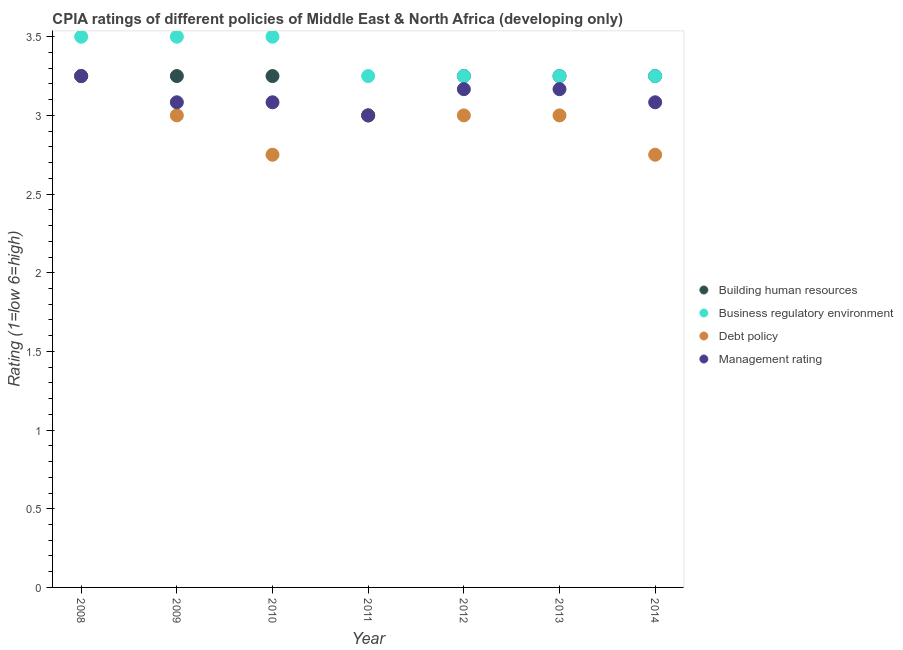How many different coloured dotlines are there?
Offer a very short reply. 4. What is the cpia rating of building human resources in 2012?
Ensure brevity in your answer.  3.25. Across all years, what is the maximum cpia rating of management?
Offer a terse response. 3.25. In which year was the cpia rating of debt policy minimum?
Offer a terse response. 2010. What is the difference between the cpia rating of building human resources in 2011 and that in 2012?
Make the answer very short. -0.25. What is the difference between the cpia rating of management in 2010 and the cpia rating of building human resources in 2013?
Make the answer very short. -0.17. What is the average cpia rating of business regulatory environment per year?
Provide a short and direct response. 3.36. In the year 2013, what is the difference between the cpia rating of management and cpia rating of debt policy?
Keep it short and to the point. 0.17. What is the ratio of the cpia rating of debt policy in 2013 to that in 2014?
Ensure brevity in your answer.  1.09. Is the difference between the cpia rating of management in 2009 and 2013 greater than the difference between the cpia rating of business regulatory environment in 2009 and 2013?
Your response must be concise. No. Is it the case that in every year, the sum of the cpia rating of building human resources and cpia rating of debt policy is greater than the sum of cpia rating of business regulatory environment and cpia rating of management?
Ensure brevity in your answer.  No. Is the cpia rating of business regulatory environment strictly less than the cpia rating of debt policy over the years?
Keep it short and to the point. No. How many dotlines are there?
Your response must be concise. 4. What is the difference between two consecutive major ticks on the Y-axis?
Provide a succinct answer. 0.5. Does the graph contain grids?
Your answer should be compact. No. Where does the legend appear in the graph?
Ensure brevity in your answer.  Center right. How many legend labels are there?
Keep it short and to the point. 4. How are the legend labels stacked?
Offer a very short reply. Vertical. What is the title of the graph?
Provide a succinct answer. CPIA ratings of different policies of Middle East & North Africa (developing only). Does "Social Assistance" appear as one of the legend labels in the graph?
Your response must be concise. No. What is the Rating (1=low 6=high) in Debt policy in 2008?
Provide a succinct answer. 3.25. What is the Rating (1=low 6=high) in Building human resources in 2009?
Your answer should be compact. 3.25. What is the Rating (1=low 6=high) in Business regulatory environment in 2009?
Your response must be concise. 3.5. What is the Rating (1=low 6=high) in Management rating in 2009?
Your response must be concise. 3.08. What is the Rating (1=low 6=high) of Building human resources in 2010?
Provide a succinct answer. 3.25. What is the Rating (1=low 6=high) of Business regulatory environment in 2010?
Keep it short and to the point. 3.5. What is the Rating (1=low 6=high) in Debt policy in 2010?
Ensure brevity in your answer.  2.75. What is the Rating (1=low 6=high) of Management rating in 2010?
Make the answer very short. 3.08. What is the Rating (1=low 6=high) of Business regulatory environment in 2011?
Provide a succinct answer. 3.25. What is the Rating (1=low 6=high) of Management rating in 2011?
Your answer should be very brief. 3. What is the Rating (1=low 6=high) of Building human resources in 2012?
Keep it short and to the point. 3.25. What is the Rating (1=low 6=high) of Business regulatory environment in 2012?
Provide a short and direct response. 3.25. What is the Rating (1=low 6=high) in Debt policy in 2012?
Make the answer very short. 3. What is the Rating (1=low 6=high) in Management rating in 2012?
Provide a succinct answer. 3.17. What is the Rating (1=low 6=high) in Building human resources in 2013?
Provide a succinct answer. 3.25. What is the Rating (1=low 6=high) in Debt policy in 2013?
Give a very brief answer. 3. What is the Rating (1=low 6=high) of Management rating in 2013?
Provide a short and direct response. 3.17. What is the Rating (1=low 6=high) of Building human resources in 2014?
Provide a succinct answer. 3.25. What is the Rating (1=low 6=high) in Business regulatory environment in 2014?
Offer a very short reply. 3.25. What is the Rating (1=low 6=high) in Debt policy in 2014?
Your response must be concise. 2.75. What is the Rating (1=low 6=high) of Management rating in 2014?
Give a very brief answer. 3.08. Across all years, what is the maximum Rating (1=low 6=high) in Building human resources?
Provide a short and direct response. 3.25. Across all years, what is the maximum Rating (1=low 6=high) in Business regulatory environment?
Provide a short and direct response. 3.5. Across all years, what is the minimum Rating (1=low 6=high) of Business regulatory environment?
Offer a terse response. 3.25. Across all years, what is the minimum Rating (1=low 6=high) of Debt policy?
Your answer should be compact. 2.75. What is the total Rating (1=low 6=high) of Building human resources in the graph?
Offer a terse response. 22.5. What is the total Rating (1=low 6=high) of Business regulatory environment in the graph?
Make the answer very short. 23.5. What is the total Rating (1=low 6=high) of Debt policy in the graph?
Ensure brevity in your answer.  20.75. What is the total Rating (1=low 6=high) of Management rating in the graph?
Offer a terse response. 21.83. What is the difference between the Rating (1=low 6=high) in Building human resources in 2008 and that in 2009?
Ensure brevity in your answer.  0. What is the difference between the Rating (1=low 6=high) of Debt policy in 2008 and that in 2009?
Provide a short and direct response. 0.25. What is the difference between the Rating (1=low 6=high) of Management rating in 2008 and that in 2009?
Offer a terse response. 0.17. What is the difference between the Rating (1=low 6=high) in Building human resources in 2008 and that in 2010?
Give a very brief answer. 0. What is the difference between the Rating (1=low 6=high) of Management rating in 2008 and that in 2010?
Offer a very short reply. 0.17. What is the difference between the Rating (1=low 6=high) in Management rating in 2008 and that in 2011?
Give a very brief answer. 0.25. What is the difference between the Rating (1=low 6=high) in Business regulatory environment in 2008 and that in 2012?
Ensure brevity in your answer.  0.25. What is the difference between the Rating (1=low 6=high) of Debt policy in 2008 and that in 2012?
Ensure brevity in your answer.  0.25. What is the difference between the Rating (1=low 6=high) in Management rating in 2008 and that in 2012?
Offer a terse response. 0.08. What is the difference between the Rating (1=low 6=high) of Building human resources in 2008 and that in 2013?
Give a very brief answer. 0. What is the difference between the Rating (1=low 6=high) in Business regulatory environment in 2008 and that in 2013?
Make the answer very short. 0.25. What is the difference between the Rating (1=low 6=high) in Management rating in 2008 and that in 2013?
Offer a very short reply. 0.08. What is the difference between the Rating (1=low 6=high) of Debt policy in 2008 and that in 2014?
Your response must be concise. 0.5. What is the difference between the Rating (1=low 6=high) of Management rating in 2008 and that in 2014?
Your answer should be compact. 0.17. What is the difference between the Rating (1=low 6=high) of Business regulatory environment in 2009 and that in 2010?
Make the answer very short. 0. What is the difference between the Rating (1=low 6=high) in Management rating in 2009 and that in 2010?
Keep it short and to the point. 0. What is the difference between the Rating (1=low 6=high) of Business regulatory environment in 2009 and that in 2011?
Provide a short and direct response. 0.25. What is the difference between the Rating (1=low 6=high) of Management rating in 2009 and that in 2011?
Make the answer very short. 0.08. What is the difference between the Rating (1=low 6=high) in Business regulatory environment in 2009 and that in 2012?
Keep it short and to the point. 0.25. What is the difference between the Rating (1=low 6=high) of Debt policy in 2009 and that in 2012?
Offer a terse response. 0. What is the difference between the Rating (1=low 6=high) of Management rating in 2009 and that in 2012?
Your answer should be compact. -0.08. What is the difference between the Rating (1=low 6=high) in Building human resources in 2009 and that in 2013?
Offer a terse response. 0. What is the difference between the Rating (1=low 6=high) in Business regulatory environment in 2009 and that in 2013?
Your answer should be compact. 0.25. What is the difference between the Rating (1=low 6=high) of Management rating in 2009 and that in 2013?
Provide a succinct answer. -0.08. What is the difference between the Rating (1=low 6=high) in Building human resources in 2009 and that in 2014?
Give a very brief answer. 0. What is the difference between the Rating (1=low 6=high) of Debt policy in 2009 and that in 2014?
Ensure brevity in your answer.  0.25. What is the difference between the Rating (1=low 6=high) of Management rating in 2009 and that in 2014?
Provide a short and direct response. -0. What is the difference between the Rating (1=low 6=high) in Building human resources in 2010 and that in 2011?
Offer a very short reply. 0.25. What is the difference between the Rating (1=low 6=high) of Debt policy in 2010 and that in 2011?
Give a very brief answer. -0.25. What is the difference between the Rating (1=low 6=high) in Management rating in 2010 and that in 2011?
Provide a succinct answer. 0.08. What is the difference between the Rating (1=low 6=high) in Management rating in 2010 and that in 2012?
Your response must be concise. -0.08. What is the difference between the Rating (1=low 6=high) of Management rating in 2010 and that in 2013?
Your answer should be very brief. -0.08. What is the difference between the Rating (1=low 6=high) in Building human resources in 2010 and that in 2014?
Offer a very short reply. 0. What is the difference between the Rating (1=low 6=high) of Business regulatory environment in 2011 and that in 2012?
Offer a very short reply. 0. What is the difference between the Rating (1=low 6=high) of Debt policy in 2011 and that in 2012?
Provide a short and direct response. 0. What is the difference between the Rating (1=low 6=high) in Building human resources in 2011 and that in 2013?
Keep it short and to the point. -0.25. What is the difference between the Rating (1=low 6=high) of Business regulatory environment in 2011 and that in 2013?
Provide a short and direct response. 0. What is the difference between the Rating (1=low 6=high) of Debt policy in 2011 and that in 2013?
Your response must be concise. 0. What is the difference between the Rating (1=low 6=high) of Debt policy in 2011 and that in 2014?
Give a very brief answer. 0.25. What is the difference between the Rating (1=low 6=high) of Management rating in 2011 and that in 2014?
Your answer should be very brief. -0.08. What is the difference between the Rating (1=low 6=high) in Debt policy in 2012 and that in 2013?
Keep it short and to the point. 0. What is the difference between the Rating (1=low 6=high) of Business regulatory environment in 2012 and that in 2014?
Your answer should be compact. 0. What is the difference between the Rating (1=low 6=high) of Management rating in 2012 and that in 2014?
Your answer should be very brief. 0.08. What is the difference between the Rating (1=low 6=high) in Building human resources in 2013 and that in 2014?
Give a very brief answer. 0. What is the difference between the Rating (1=low 6=high) in Business regulatory environment in 2013 and that in 2014?
Give a very brief answer. 0. What is the difference between the Rating (1=low 6=high) of Debt policy in 2013 and that in 2014?
Offer a terse response. 0.25. What is the difference between the Rating (1=low 6=high) of Management rating in 2013 and that in 2014?
Your answer should be very brief. 0.08. What is the difference between the Rating (1=low 6=high) of Building human resources in 2008 and the Rating (1=low 6=high) of Management rating in 2009?
Make the answer very short. 0.17. What is the difference between the Rating (1=low 6=high) in Business regulatory environment in 2008 and the Rating (1=low 6=high) in Debt policy in 2009?
Your answer should be very brief. 0.5. What is the difference between the Rating (1=low 6=high) in Business regulatory environment in 2008 and the Rating (1=low 6=high) in Management rating in 2009?
Your response must be concise. 0.42. What is the difference between the Rating (1=low 6=high) of Debt policy in 2008 and the Rating (1=low 6=high) of Management rating in 2009?
Offer a very short reply. 0.17. What is the difference between the Rating (1=low 6=high) in Building human resources in 2008 and the Rating (1=low 6=high) in Business regulatory environment in 2010?
Make the answer very short. -0.25. What is the difference between the Rating (1=low 6=high) in Building human resources in 2008 and the Rating (1=low 6=high) in Management rating in 2010?
Provide a succinct answer. 0.17. What is the difference between the Rating (1=low 6=high) in Business regulatory environment in 2008 and the Rating (1=low 6=high) in Management rating in 2010?
Offer a terse response. 0.42. What is the difference between the Rating (1=low 6=high) of Building human resources in 2008 and the Rating (1=low 6=high) of Debt policy in 2011?
Make the answer very short. 0.25. What is the difference between the Rating (1=low 6=high) of Building human resources in 2008 and the Rating (1=low 6=high) of Management rating in 2011?
Your response must be concise. 0.25. What is the difference between the Rating (1=low 6=high) of Business regulatory environment in 2008 and the Rating (1=low 6=high) of Debt policy in 2011?
Keep it short and to the point. 0.5. What is the difference between the Rating (1=low 6=high) of Business regulatory environment in 2008 and the Rating (1=low 6=high) of Management rating in 2011?
Your response must be concise. 0.5. What is the difference between the Rating (1=low 6=high) in Debt policy in 2008 and the Rating (1=low 6=high) in Management rating in 2011?
Your answer should be very brief. 0.25. What is the difference between the Rating (1=low 6=high) in Building human resources in 2008 and the Rating (1=low 6=high) in Business regulatory environment in 2012?
Offer a terse response. 0. What is the difference between the Rating (1=low 6=high) of Building human resources in 2008 and the Rating (1=low 6=high) of Management rating in 2012?
Offer a very short reply. 0.08. What is the difference between the Rating (1=low 6=high) in Business regulatory environment in 2008 and the Rating (1=low 6=high) in Debt policy in 2012?
Your answer should be compact. 0.5. What is the difference between the Rating (1=low 6=high) of Debt policy in 2008 and the Rating (1=low 6=high) of Management rating in 2012?
Give a very brief answer. 0.08. What is the difference between the Rating (1=low 6=high) of Building human resources in 2008 and the Rating (1=low 6=high) of Business regulatory environment in 2013?
Make the answer very short. 0. What is the difference between the Rating (1=low 6=high) in Building human resources in 2008 and the Rating (1=low 6=high) in Management rating in 2013?
Ensure brevity in your answer.  0.08. What is the difference between the Rating (1=low 6=high) of Business regulatory environment in 2008 and the Rating (1=low 6=high) of Debt policy in 2013?
Ensure brevity in your answer.  0.5. What is the difference between the Rating (1=low 6=high) in Business regulatory environment in 2008 and the Rating (1=low 6=high) in Management rating in 2013?
Provide a succinct answer. 0.33. What is the difference between the Rating (1=low 6=high) in Debt policy in 2008 and the Rating (1=low 6=high) in Management rating in 2013?
Offer a very short reply. 0.08. What is the difference between the Rating (1=low 6=high) in Building human resources in 2008 and the Rating (1=low 6=high) in Business regulatory environment in 2014?
Your answer should be compact. 0. What is the difference between the Rating (1=low 6=high) in Building human resources in 2008 and the Rating (1=low 6=high) in Management rating in 2014?
Your answer should be very brief. 0.17. What is the difference between the Rating (1=low 6=high) in Business regulatory environment in 2008 and the Rating (1=low 6=high) in Debt policy in 2014?
Ensure brevity in your answer.  0.75. What is the difference between the Rating (1=low 6=high) in Business regulatory environment in 2008 and the Rating (1=low 6=high) in Management rating in 2014?
Give a very brief answer. 0.42. What is the difference between the Rating (1=low 6=high) of Building human resources in 2009 and the Rating (1=low 6=high) of Management rating in 2010?
Offer a terse response. 0.17. What is the difference between the Rating (1=low 6=high) in Business regulatory environment in 2009 and the Rating (1=low 6=high) in Management rating in 2010?
Provide a short and direct response. 0.42. What is the difference between the Rating (1=low 6=high) in Debt policy in 2009 and the Rating (1=low 6=high) in Management rating in 2010?
Give a very brief answer. -0.08. What is the difference between the Rating (1=low 6=high) in Building human resources in 2009 and the Rating (1=low 6=high) in Business regulatory environment in 2011?
Your response must be concise. 0. What is the difference between the Rating (1=low 6=high) of Building human resources in 2009 and the Rating (1=low 6=high) of Business regulatory environment in 2012?
Keep it short and to the point. 0. What is the difference between the Rating (1=low 6=high) of Building human resources in 2009 and the Rating (1=low 6=high) of Management rating in 2012?
Your response must be concise. 0.08. What is the difference between the Rating (1=low 6=high) in Business regulatory environment in 2009 and the Rating (1=low 6=high) in Debt policy in 2012?
Your answer should be compact. 0.5. What is the difference between the Rating (1=low 6=high) in Business regulatory environment in 2009 and the Rating (1=low 6=high) in Management rating in 2012?
Offer a terse response. 0.33. What is the difference between the Rating (1=low 6=high) of Debt policy in 2009 and the Rating (1=low 6=high) of Management rating in 2012?
Offer a very short reply. -0.17. What is the difference between the Rating (1=low 6=high) in Building human resources in 2009 and the Rating (1=low 6=high) in Business regulatory environment in 2013?
Offer a very short reply. 0. What is the difference between the Rating (1=low 6=high) of Building human resources in 2009 and the Rating (1=low 6=high) of Debt policy in 2013?
Make the answer very short. 0.25. What is the difference between the Rating (1=low 6=high) of Building human resources in 2009 and the Rating (1=low 6=high) of Management rating in 2013?
Keep it short and to the point. 0.08. What is the difference between the Rating (1=low 6=high) of Business regulatory environment in 2009 and the Rating (1=low 6=high) of Management rating in 2013?
Your answer should be very brief. 0.33. What is the difference between the Rating (1=low 6=high) in Business regulatory environment in 2009 and the Rating (1=low 6=high) in Management rating in 2014?
Give a very brief answer. 0.42. What is the difference between the Rating (1=low 6=high) of Debt policy in 2009 and the Rating (1=low 6=high) of Management rating in 2014?
Your answer should be very brief. -0.08. What is the difference between the Rating (1=low 6=high) in Building human resources in 2010 and the Rating (1=low 6=high) in Debt policy in 2011?
Give a very brief answer. 0.25. What is the difference between the Rating (1=low 6=high) in Building human resources in 2010 and the Rating (1=low 6=high) in Business regulatory environment in 2012?
Provide a short and direct response. 0. What is the difference between the Rating (1=low 6=high) of Building human resources in 2010 and the Rating (1=low 6=high) of Management rating in 2012?
Make the answer very short. 0.08. What is the difference between the Rating (1=low 6=high) of Business regulatory environment in 2010 and the Rating (1=low 6=high) of Management rating in 2012?
Your answer should be very brief. 0.33. What is the difference between the Rating (1=low 6=high) of Debt policy in 2010 and the Rating (1=low 6=high) of Management rating in 2012?
Ensure brevity in your answer.  -0.42. What is the difference between the Rating (1=low 6=high) of Building human resources in 2010 and the Rating (1=low 6=high) of Business regulatory environment in 2013?
Make the answer very short. 0. What is the difference between the Rating (1=low 6=high) of Building human resources in 2010 and the Rating (1=low 6=high) of Management rating in 2013?
Keep it short and to the point. 0.08. What is the difference between the Rating (1=low 6=high) of Debt policy in 2010 and the Rating (1=low 6=high) of Management rating in 2013?
Your answer should be compact. -0.42. What is the difference between the Rating (1=low 6=high) of Building human resources in 2010 and the Rating (1=low 6=high) of Management rating in 2014?
Give a very brief answer. 0.17. What is the difference between the Rating (1=low 6=high) in Business regulatory environment in 2010 and the Rating (1=low 6=high) in Debt policy in 2014?
Offer a very short reply. 0.75. What is the difference between the Rating (1=low 6=high) in Business regulatory environment in 2010 and the Rating (1=low 6=high) in Management rating in 2014?
Your response must be concise. 0.42. What is the difference between the Rating (1=low 6=high) of Business regulatory environment in 2011 and the Rating (1=low 6=high) of Debt policy in 2012?
Offer a very short reply. 0.25. What is the difference between the Rating (1=low 6=high) of Business regulatory environment in 2011 and the Rating (1=low 6=high) of Management rating in 2012?
Your response must be concise. 0.08. What is the difference between the Rating (1=low 6=high) of Building human resources in 2011 and the Rating (1=low 6=high) of Management rating in 2013?
Ensure brevity in your answer.  -0.17. What is the difference between the Rating (1=low 6=high) of Business regulatory environment in 2011 and the Rating (1=low 6=high) of Management rating in 2013?
Keep it short and to the point. 0.08. What is the difference between the Rating (1=low 6=high) of Building human resources in 2011 and the Rating (1=low 6=high) of Business regulatory environment in 2014?
Make the answer very short. -0.25. What is the difference between the Rating (1=low 6=high) of Building human resources in 2011 and the Rating (1=low 6=high) of Debt policy in 2014?
Offer a very short reply. 0.25. What is the difference between the Rating (1=low 6=high) in Building human resources in 2011 and the Rating (1=low 6=high) in Management rating in 2014?
Give a very brief answer. -0.08. What is the difference between the Rating (1=low 6=high) in Debt policy in 2011 and the Rating (1=low 6=high) in Management rating in 2014?
Ensure brevity in your answer.  -0.08. What is the difference between the Rating (1=low 6=high) in Building human resources in 2012 and the Rating (1=low 6=high) in Debt policy in 2013?
Your answer should be very brief. 0.25. What is the difference between the Rating (1=low 6=high) in Building human resources in 2012 and the Rating (1=low 6=high) in Management rating in 2013?
Your answer should be very brief. 0.08. What is the difference between the Rating (1=low 6=high) in Business regulatory environment in 2012 and the Rating (1=low 6=high) in Debt policy in 2013?
Your answer should be very brief. 0.25. What is the difference between the Rating (1=low 6=high) in Business regulatory environment in 2012 and the Rating (1=low 6=high) in Management rating in 2013?
Keep it short and to the point. 0.08. What is the difference between the Rating (1=low 6=high) in Debt policy in 2012 and the Rating (1=low 6=high) in Management rating in 2013?
Offer a terse response. -0.17. What is the difference between the Rating (1=low 6=high) of Building human resources in 2012 and the Rating (1=low 6=high) of Business regulatory environment in 2014?
Your answer should be very brief. 0. What is the difference between the Rating (1=low 6=high) of Debt policy in 2012 and the Rating (1=low 6=high) of Management rating in 2014?
Your answer should be very brief. -0.08. What is the difference between the Rating (1=low 6=high) of Building human resources in 2013 and the Rating (1=low 6=high) of Business regulatory environment in 2014?
Provide a short and direct response. 0. What is the difference between the Rating (1=low 6=high) in Building human resources in 2013 and the Rating (1=low 6=high) in Debt policy in 2014?
Provide a succinct answer. 0.5. What is the difference between the Rating (1=low 6=high) in Building human resources in 2013 and the Rating (1=low 6=high) in Management rating in 2014?
Make the answer very short. 0.17. What is the difference between the Rating (1=low 6=high) in Business regulatory environment in 2013 and the Rating (1=low 6=high) in Debt policy in 2014?
Your answer should be very brief. 0.5. What is the difference between the Rating (1=low 6=high) in Debt policy in 2013 and the Rating (1=low 6=high) in Management rating in 2014?
Provide a succinct answer. -0.08. What is the average Rating (1=low 6=high) of Building human resources per year?
Keep it short and to the point. 3.21. What is the average Rating (1=low 6=high) of Business regulatory environment per year?
Your answer should be very brief. 3.36. What is the average Rating (1=low 6=high) of Debt policy per year?
Offer a terse response. 2.96. What is the average Rating (1=low 6=high) of Management rating per year?
Give a very brief answer. 3.12. In the year 2008, what is the difference between the Rating (1=low 6=high) of Building human resources and Rating (1=low 6=high) of Business regulatory environment?
Give a very brief answer. -0.25. In the year 2008, what is the difference between the Rating (1=low 6=high) in Building human resources and Rating (1=low 6=high) in Management rating?
Your answer should be compact. 0. In the year 2008, what is the difference between the Rating (1=low 6=high) in Business regulatory environment and Rating (1=low 6=high) in Debt policy?
Offer a terse response. 0.25. In the year 2009, what is the difference between the Rating (1=low 6=high) of Building human resources and Rating (1=low 6=high) of Debt policy?
Offer a terse response. 0.25. In the year 2009, what is the difference between the Rating (1=low 6=high) of Building human resources and Rating (1=low 6=high) of Management rating?
Offer a very short reply. 0.17. In the year 2009, what is the difference between the Rating (1=low 6=high) in Business regulatory environment and Rating (1=low 6=high) in Management rating?
Offer a terse response. 0.42. In the year 2009, what is the difference between the Rating (1=low 6=high) of Debt policy and Rating (1=low 6=high) of Management rating?
Offer a very short reply. -0.08. In the year 2010, what is the difference between the Rating (1=low 6=high) in Building human resources and Rating (1=low 6=high) in Debt policy?
Your answer should be very brief. 0.5. In the year 2010, what is the difference between the Rating (1=low 6=high) of Business regulatory environment and Rating (1=low 6=high) of Management rating?
Your answer should be compact. 0.42. In the year 2010, what is the difference between the Rating (1=low 6=high) of Debt policy and Rating (1=low 6=high) of Management rating?
Your response must be concise. -0.33. In the year 2011, what is the difference between the Rating (1=low 6=high) of Building human resources and Rating (1=low 6=high) of Debt policy?
Your answer should be compact. 0. In the year 2012, what is the difference between the Rating (1=low 6=high) in Building human resources and Rating (1=low 6=high) in Management rating?
Provide a succinct answer. 0.08. In the year 2012, what is the difference between the Rating (1=low 6=high) in Business regulatory environment and Rating (1=low 6=high) in Management rating?
Your answer should be very brief. 0.08. In the year 2013, what is the difference between the Rating (1=low 6=high) of Building human resources and Rating (1=low 6=high) of Debt policy?
Provide a short and direct response. 0.25. In the year 2013, what is the difference between the Rating (1=low 6=high) of Building human resources and Rating (1=low 6=high) of Management rating?
Give a very brief answer. 0.08. In the year 2013, what is the difference between the Rating (1=low 6=high) in Business regulatory environment and Rating (1=low 6=high) in Debt policy?
Your answer should be very brief. 0.25. In the year 2013, what is the difference between the Rating (1=low 6=high) of Business regulatory environment and Rating (1=low 6=high) of Management rating?
Provide a succinct answer. 0.08. In the year 2014, what is the difference between the Rating (1=low 6=high) in Building human resources and Rating (1=low 6=high) in Business regulatory environment?
Provide a succinct answer. 0. In the year 2014, what is the difference between the Rating (1=low 6=high) in Building human resources and Rating (1=low 6=high) in Management rating?
Provide a short and direct response. 0.17. In the year 2014, what is the difference between the Rating (1=low 6=high) of Debt policy and Rating (1=low 6=high) of Management rating?
Give a very brief answer. -0.33. What is the ratio of the Rating (1=low 6=high) in Business regulatory environment in 2008 to that in 2009?
Keep it short and to the point. 1. What is the ratio of the Rating (1=low 6=high) of Management rating in 2008 to that in 2009?
Provide a succinct answer. 1.05. What is the ratio of the Rating (1=low 6=high) of Building human resources in 2008 to that in 2010?
Offer a very short reply. 1. What is the ratio of the Rating (1=low 6=high) in Debt policy in 2008 to that in 2010?
Your answer should be very brief. 1.18. What is the ratio of the Rating (1=low 6=high) in Management rating in 2008 to that in 2010?
Offer a terse response. 1.05. What is the ratio of the Rating (1=low 6=high) of Building human resources in 2008 to that in 2011?
Your answer should be compact. 1.08. What is the ratio of the Rating (1=low 6=high) in Debt policy in 2008 to that in 2011?
Make the answer very short. 1.08. What is the ratio of the Rating (1=low 6=high) in Management rating in 2008 to that in 2011?
Provide a succinct answer. 1.08. What is the ratio of the Rating (1=low 6=high) in Debt policy in 2008 to that in 2012?
Offer a terse response. 1.08. What is the ratio of the Rating (1=low 6=high) of Management rating in 2008 to that in 2012?
Ensure brevity in your answer.  1.03. What is the ratio of the Rating (1=low 6=high) in Business regulatory environment in 2008 to that in 2013?
Make the answer very short. 1.08. What is the ratio of the Rating (1=low 6=high) in Management rating in 2008 to that in 2013?
Provide a succinct answer. 1.03. What is the ratio of the Rating (1=low 6=high) in Business regulatory environment in 2008 to that in 2014?
Offer a very short reply. 1.08. What is the ratio of the Rating (1=low 6=high) in Debt policy in 2008 to that in 2014?
Provide a short and direct response. 1.18. What is the ratio of the Rating (1=low 6=high) in Management rating in 2008 to that in 2014?
Give a very brief answer. 1.05. What is the ratio of the Rating (1=low 6=high) of Debt policy in 2009 to that in 2010?
Your response must be concise. 1.09. What is the ratio of the Rating (1=low 6=high) in Management rating in 2009 to that in 2010?
Offer a terse response. 1. What is the ratio of the Rating (1=low 6=high) in Building human resources in 2009 to that in 2011?
Provide a succinct answer. 1.08. What is the ratio of the Rating (1=low 6=high) in Business regulatory environment in 2009 to that in 2011?
Offer a very short reply. 1.08. What is the ratio of the Rating (1=low 6=high) of Management rating in 2009 to that in 2011?
Make the answer very short. 1.03. What is the ratio of the Rating (1=low 6=high) in Debt policy in 2009 to that in 2012?
Ensure brevity in your answer.  1. What is the ratio of the Rating (1=low 6=high) in Management rating in 2009 to that in 2012?
Your answer should be compact. 0.97. What is the ratio of the Rating (1=low 6=high) of Management rating in 2009 to that in 2013?
Give a very brief answer. 0.97. What is the ratio of the Rating (1=low 6=high) in Building human resources in 2010 to that in 2011?
Your response must be concise. 1.08. What is the ratio of the Rating (1=low 6=high) of Debt policy in 2010 to that in 2011?
Offer a very short reply. 0.92. What is the ratio of the Rating (1=low 6=high) of Management rating in 2010 to that in 2011?
Your answer should be very brief. 1.03. What is the ratio of the Rating (1=low 6=high) of Building human resources in 2010 to that in 2012?
Make the answer very short. 1. What is the ratio of the Rating (1=low 6=high) of Management rating in 2010 to that in 2012?
Keep it short and to the point. 0.97. What is the ratio of the Rating (1=low 6=high) in Building human resources in 2010 to that in 2013?
Keep it short and to the point. 1. What is the ratio of the Rating (1=low 6=high) in Management rating in 2010 to that in 2013?
Make the answer very short. 0.97. What is the ratio of the Rating (1=low 6=high) in Business regulatory environment in 2010 to that in 2014?
Keep it short and to the point. 1.08. What is the ratio of the Rating (1=low 6=high) in Management rating in 2010 to that in 2014?
Make the answer very short. 1. What is the ratio of the Rating (1=low 6=high) of Building human resources in 2011 to that in 2012?
Ensure brevity in your answer.  0.92. What is the ratio of the Rating (1=low 6=high) in Debt policy in 2011 to that in 2012?
Your answer should be compact. 1. What is the ratio of the Rating (1=low 6=high) of Management rating in 2011 to that in 2012?
Ensure brevity in your answer.  0.95. What is the ratio of the Rating (1=low 6=high) in Building human resources in 2011 to that in 2013?
Offer a terse response. 0.92. What is the ratio of the Rating (1=low 6=high) in Building human resources in 2011 to that in 2014?
Provide a succinct answer. 0.92. What is the ratio of the Rating (1=low 6=high) in Business regulatory environment in 2011 to that in 2014?
Offer a terse response. 1. What is the ratio of the Rating (1=low 6=high) of Management rating in 2011 to that in 2014?
Ensure brevity in your answer.  0.97. What is the ratio of the Rating (1=low 6=high) in Debt policy in 2012 to that in 2013?
Your response must be concise. 1. What is the ratio of the Rating (1=low 6=high) in Building human resources in 2012 to that in 2014?
Your response must be concise. 1. What is the ratio of the Rating (1=low 6=high) of Business regulatory environment in 2012 to that in 2014?
Provide a short and direct response. 1. What is the ratio of the Rating (1=low 6=high) of Business regulatory environment in 2013 to that in 2014?
Give a very brief answer. 1. What is the ratio of the Rating (1=low 6=high) in Debt policy in 2013 to that in 2014?
Keep it short and to the point. 1.09. What is the difference between the highest and the second highest Rating (1=low 6=high) in Business regulatory environment?
Provide a short and direct response. 0. What is the difference between the highest and the second highest Rating (1=low 6=high) of Management rating?
Ensure brevity in your answer.  0.08. What is the difference between the highest and the lowest Rating (1=low 6=high) of Debt policy?
Your response must be concise. 0.5. 